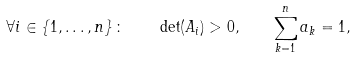<formula> <loc_0><loc_0><loc_500><loc_500>\forall i \in \left \{ 1 , \dots , n \right \} \colon \quad \det ( A _ { i } ) > 0 , \quad \sum _ { k = 1 } ^ { n } a _ { k } = 1 ,</formula> 